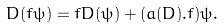<formula> <loc_0><loc_0><loc_500><loc_500>D ( f \psi ) = f D ( \psi ) + ( a ( D ) . f ) \psi .</formula> 